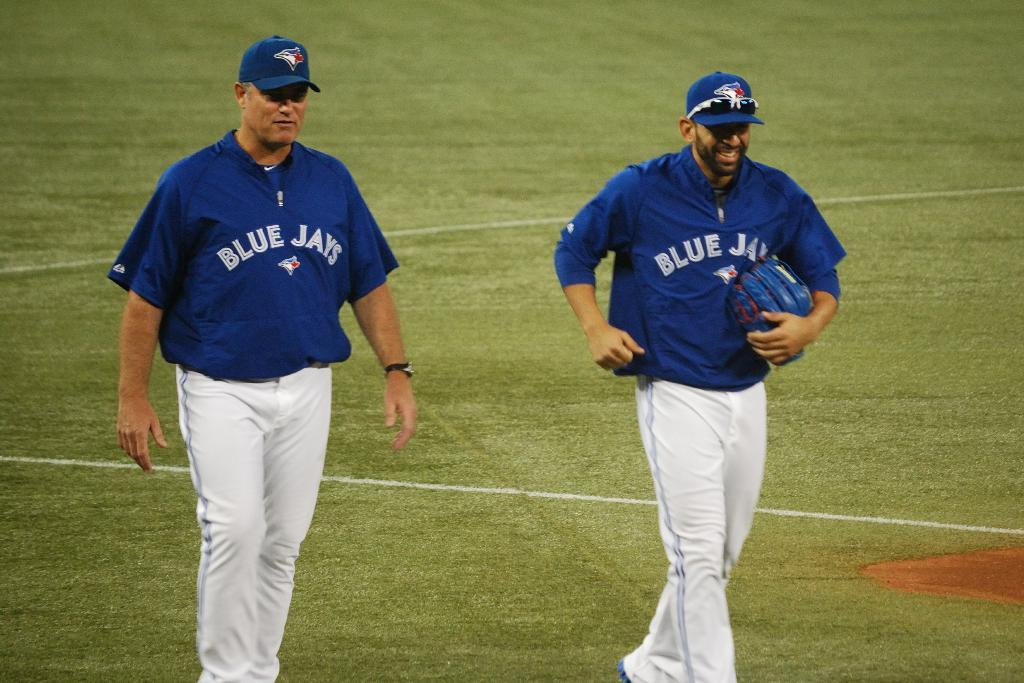What type of vegetation is present on the ground in the image? There is green grass on the ground in the image. How many people are in the image? There are two men in the image. What are the men wearing on their heads? The men are wearing blue hats. Can you see a zebra grazing on the grass in the image? No, there is no zebra present in the image. What is the mass of the grass in the image? The mass of the grass cannot be determined from the image alone. 